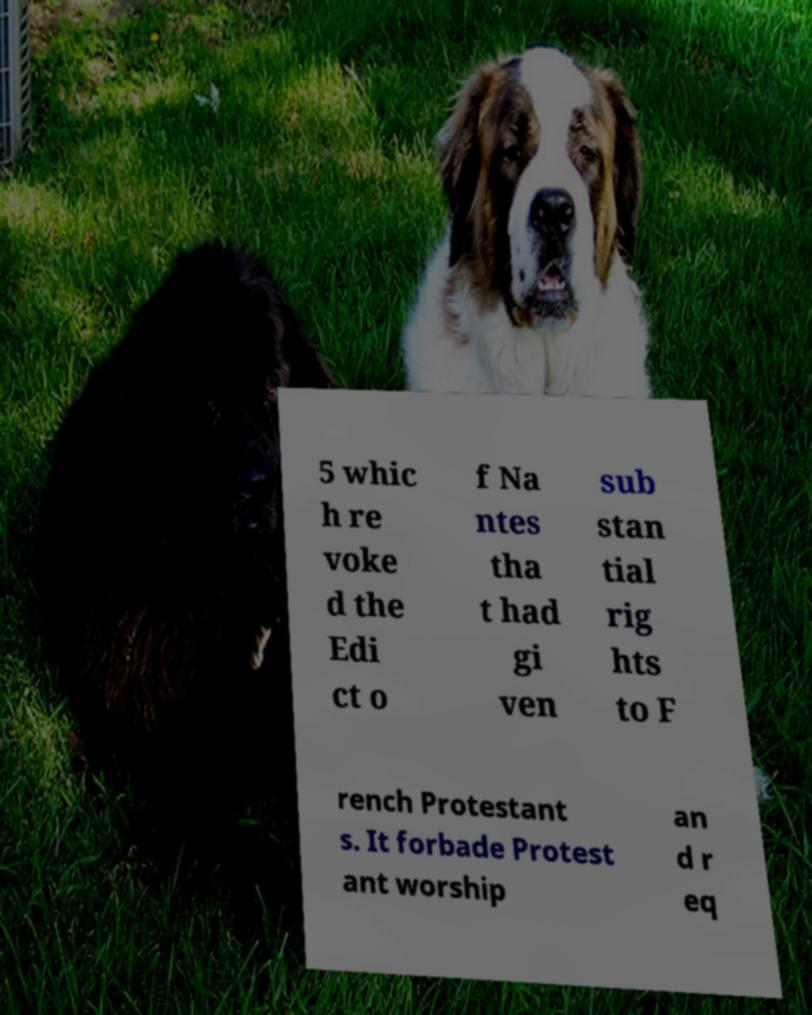Could you assist in decoding the text presented in this image and type it out clearly? 5 whic h re voke d the Edi ct o f Na ntes tha t had gi ven sub stan tial rig hts to F rench Protestant s. It forbade Protest ant worship an d r eq 